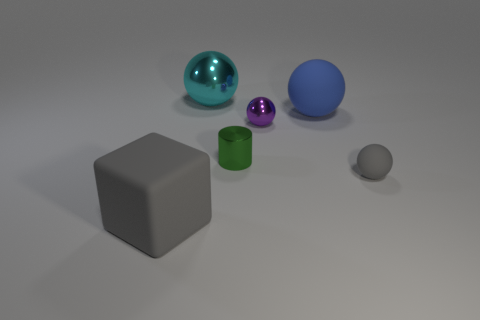Is there anything else that is the same shape as the small green object?
Keep it short and to the point. No. There is a cyan thing that is the same size as the gray rubber block; what is its material?
Provide a short and direct response. Metal. Is the tiny green shiny object the same shape as the tiny gray rubber object?
Give a very brief answer. No. Do the rubber object on the left side of the large cyan shiny ball and the metallic thing that is in front of the purple metallic sphere have the same size?
Keep it short and to the point. No. Are there an equal number of tiny green metallic objects that are behind the tiny matte sphere and shiny cylinders that are in front of the large cyan object?
Keep it short and to the point. Yes. There is a green thing; is its size the same as the rubber ball in front of the blue object?
Make the answer very short. Yes. The tiny purple thing to the right of the gray object that is on the left side of the big cyan metal ball is made of what material?
Your response must be concise. Metal. Are there an equal number of big cyan metallic objects that are in front of the big cyan shiny thing and green rubber things?
Ensure brevity in your answer.  Yes. How big is the object that is both left of the small shiny cylinder and in front of the tiny green object?
Your answer should be compact. Large. There is a metallic sphere on the left side of the metal ball that is in front of the big cyan shiny sphere; what is its color?
Your answer should be very brief. Cyan. 